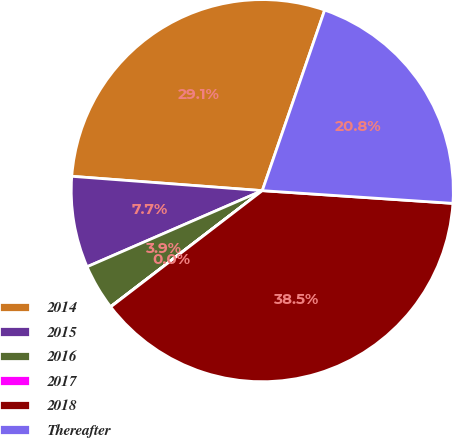<chart> <loc_0><loc_0><loc_500><loc_500><pie_chart><fcel>2014<fcel>2015<fcel>2016<fcel>2017<fcel>2018<fcel>Thereafter<nl><fcel>29.1%<fcel>7.72%<fcel>3.87%<fcel>0.02%<fcel>38.53%<fcel>20.77%<nl></chart> 